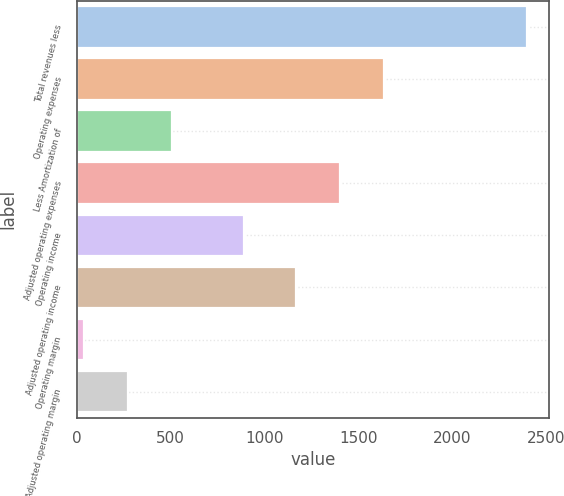<chart> <loc_0><loc_0><loc_500><loc_500><bar_chart><fcel>Total revenues less<fcel>Operating expenses<fcel>Less Amortization of<fcel>Adjusted operating expenses<fcel>Operating income<fcel>Adjusted operating income<fcel>Operating margin<fcel>Adjusted operating margin<nl><fcel>2397<fcel>1637<fcel>509<fcel>1401<fcel>890<fcel>1165<fcel>37<fcel>273<nl></chart> 